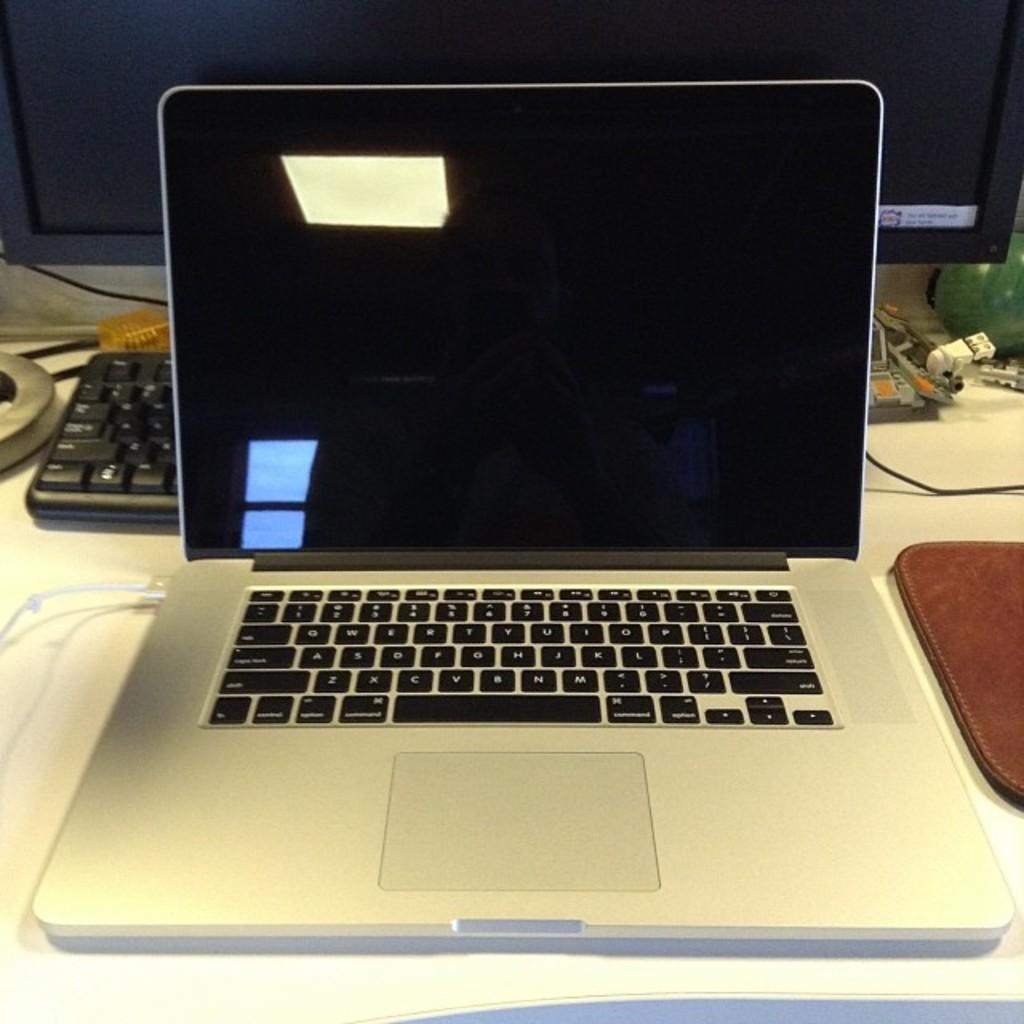What key is above the "g" key?
Ensure brevity in your answer.  T. 